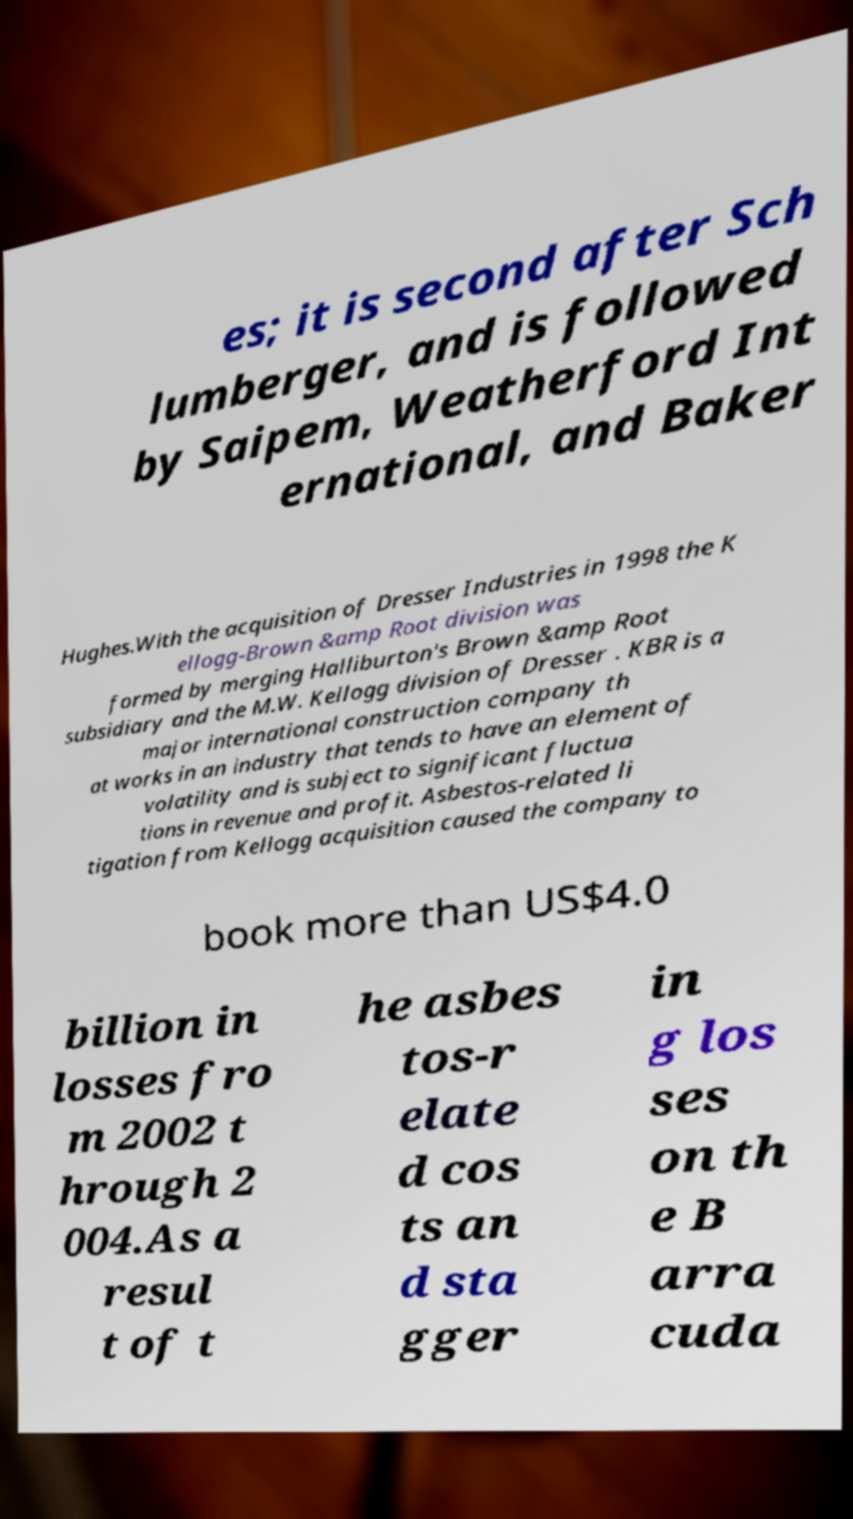Can you accurately transcribe the text from the provided image for me? es; it is second after Sch lumberger, and is followed by Saipem, Weatherford Int ernational, and Baker Hughes.With the acquisition of Dresser Industries in 1998 the K ellogg-Brown &amp Root division was formed by merging Halliburton's Brown &amp Root subsidiary and the M.W. Kellogg division of Dresser . KBR is a major international construction company th at works in an industry that tends to have an element of volatility and is subject to significant fluctua tions in revenue and profit. Asbestos-related li tigation from Kellogg acquisition caused the company to book more than US$4.0 billion in losses fro m 2002 t hrough 2 004.As a resul t of t he asbes tos-r elate d cos ts an d sta gger in g los ses on th e B arra cuda 